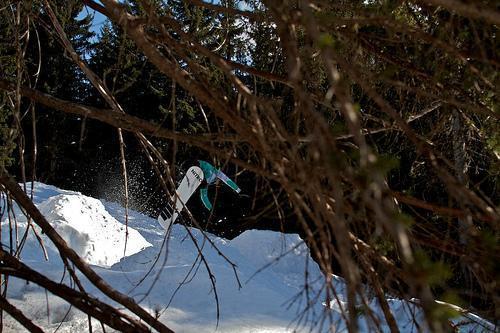How many things are in the tree?
Give a very brief answer. 1. 